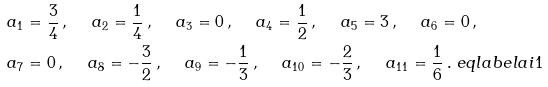Convert formula to latex. <formula><loc_0><loc_0><loc_500><loc_500>\ a _ { 1 } & = \frac { 3 } { 4 } \, , \quad \ a _ { 2 } = \frac { 1 } { 4 } \, , \quad \ a _ { 3 } = 0 \, , \quad \ a _ { 4 } = \frac { 1 } { 2 } \, , \quad \ a _ { 5 } = 3 \, , \quad \ a _ { 6 } = 0 \, , \\ \ a _ { 7 } & = 0 \, , \quad \ a _ { 8 } = - \frac { 3 } { 2 } \, , \quad \ a _ { 9 } = - \frac { 1 } { 3 } \, , \quad \ a _ { 1 0 } = - \frac { 2 } { 3 } \, , \quad \ a _ { 1 1 } = \frac { 1 } { 6 } \, . \ e q l a b e l { a i 1 }</formula> 